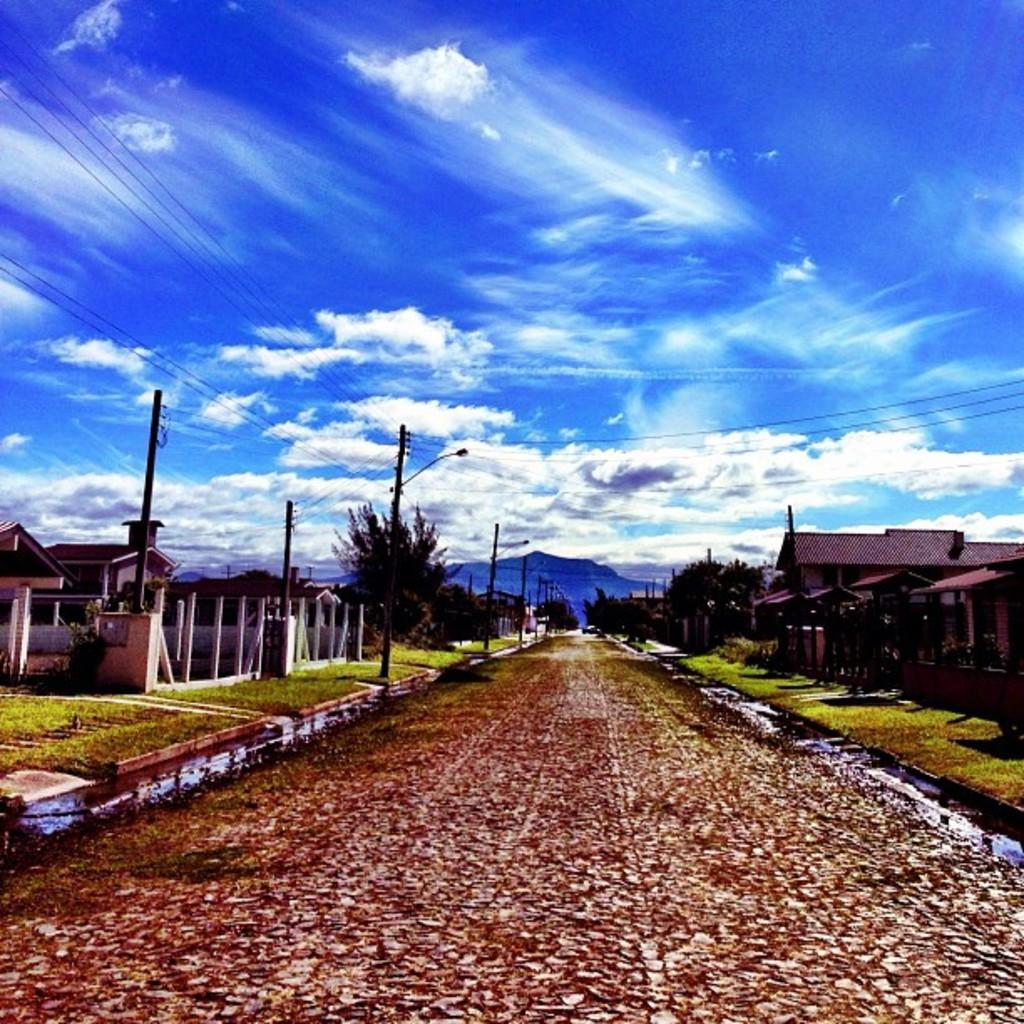How would you summarize this image in a sentence or two? At the top we can see a clear blue sky with clouds. On either side of the road we can see trees, grass and houses. At the left side of the picture we can see current polls. 